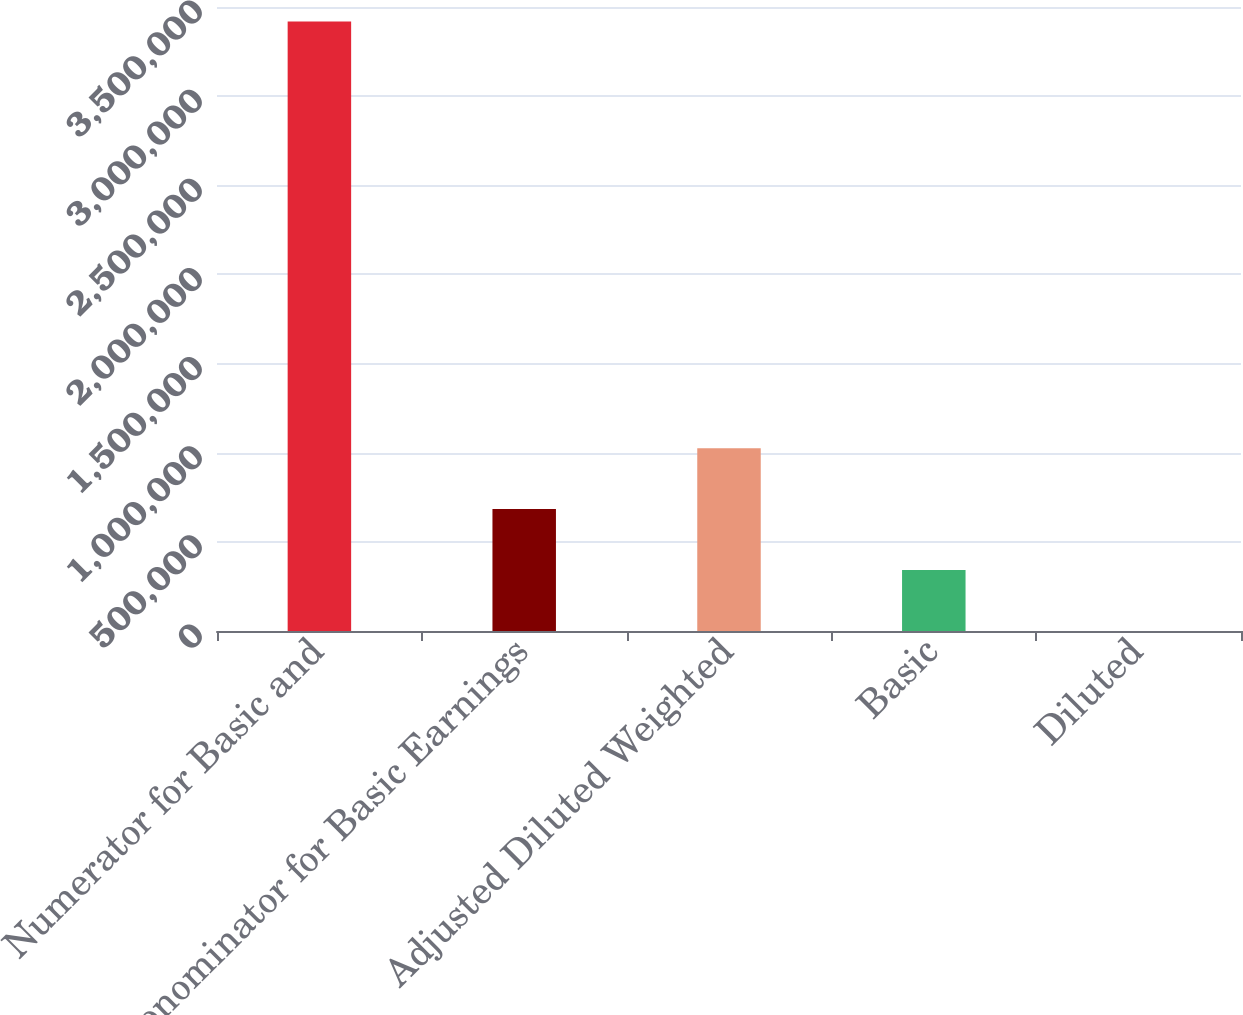Convert chart to OTSL. <chart><loc_0><loc_0><loc_500><loc_500><bar_chart><fcel>Numerator for Basic and<fcel>Denominator for Basic Earnings<fcel>Adjusted Diluted Weighted<fcel>Basic<fcel>Diluted<nl><fcel>3.41904e+06<fcel>683813<fcel>1.02572e+06<fcel>341909<fcel>5.89<nl></chart> 